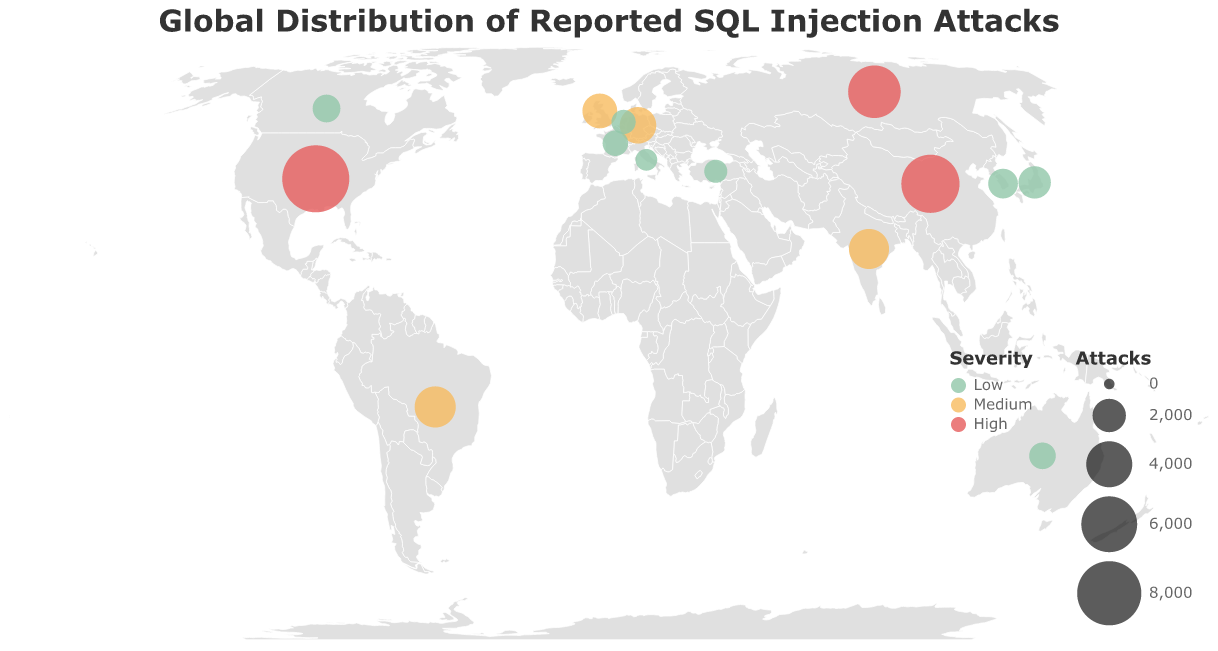What is the title of the plot? The title of the plot is a straightforward visual element displayed at the top of the figure.
Answer: Global Distribution of Reported SQL Injection Attacks Which country has the highest number of SQL injection attacks? The figure visualizes data points where the size of each circle represents the number of attacks. The largest circle is located in the United States, indicating it has the highest number of attacks.
Answer: United States What color represents high severity attacks? In the figure, different severities are represented by different colors in the legend. High severity attacks are marked by the color red.
Answer: Red How many countries reported medium severity SQL injection attacks? The figure uses different colors to indicate the severity levels for each country. By counting the circles colored in orange (representing medium severity), we find that there are 4 countries: Brazil, India, Germany, and the United Kingdom.
Answer: 4 Compare the number of attacks in China and Russia. Which country has more attacks? To compare, we look at the corresponding circles for China and Russia and their numeric values. China has 6531 attacks, while Russia has 5289 attacks, indicating that China has more attacks.
Answer: China Which country has the lowest number of SQL injection attacks? The plot shows various circles of different sizes. The smallest circle corresponds to Italy, which has the least number of reported attacks, totalling 721.
Answer: Italy Calculate the average number of SQL injection attacks for the countries with low severity. To find the average, sum the attacks in countries with low severity: Japan (1876), South Korea (1543), Canada (1321), Australia (1198), France (1087), Netherlands (956), Turkey (843), and Italy (721), which totals 9545. Divide this by the number of countries (8). 9545 / 8 = 1193.125
Answer: 1193.125 Which countries fall under the ‘Low’ severity category? The countries falling under the 'Low' severity category can be identified by the corresponding color in the legend. These countries include Japan, South Korea, Canada, Australia, France, Netherlands, Turkey, and Italy.
Answer: Japan, South Korea, Canada, Australia, France, Netherlands, Turkey, Italy What is the distribution of SQL injection attacks severity across continents? By observing the plot and severity colors spread across continents: North America (USA - High, Canada - Low), South America (Brazil - Medium), Europe (Germany, UK - Medium; France, Netherlands, Italy - Low), Asia (China, Russia, India - High/Medium; Japan, South Korea - Low), and Australia (Low).
Answer: North America: High/Low, South America: Medium, Europe: Medium/Low, Asia: High/Medium/Low, Australia: Low 